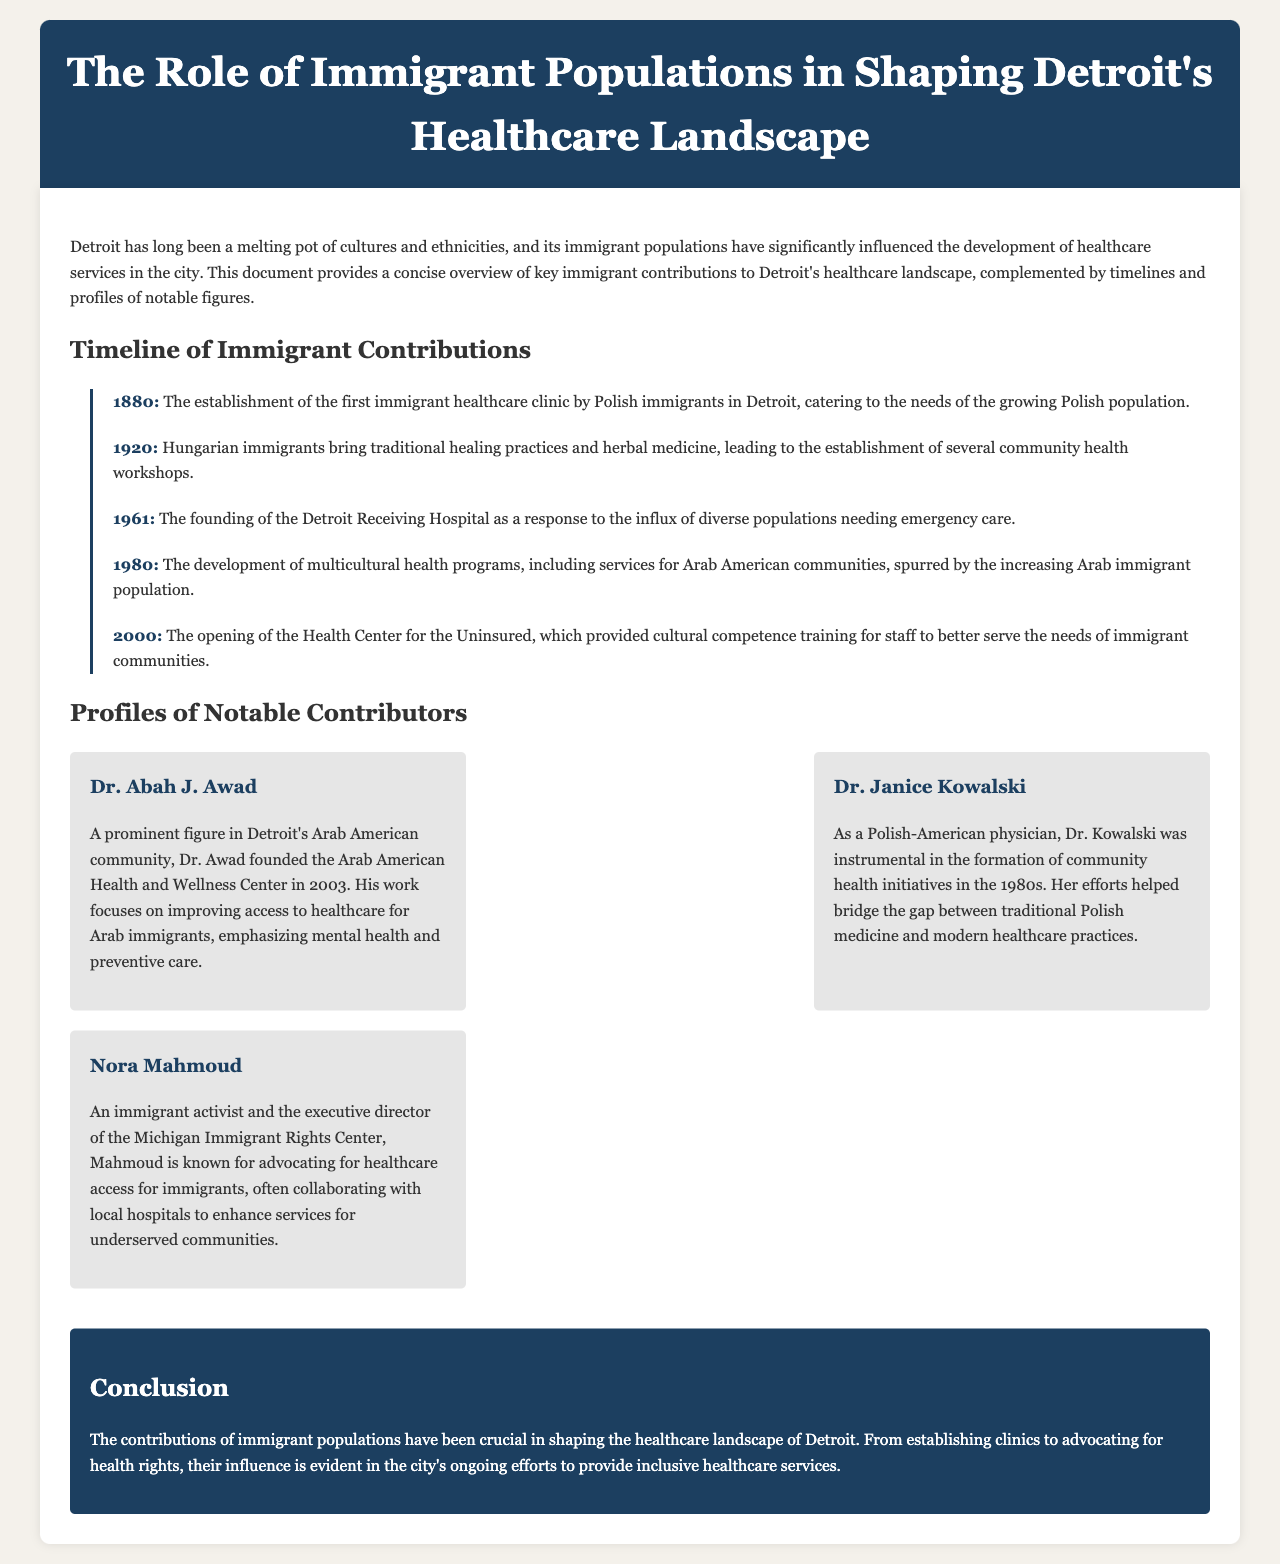What year was the first immigrant healthcare clinic established? The first immigrant healthcare clinic was established in the year 1880 according to the timeline in the document.
Answer: 1880 Who founded the Arab American Health and Wellness Center? The document states that Dr. Abah J. Awad founded the Arab American Health and Wellness Center in 2003.
Answer: Dr. Abah J. Awad What service was developed in 1980 for the Arab American communities? The timeline indicates that multicultural health programs were developed, specifically including services for Arab American communities in 1980.
Answer: Multicultural health programs Which immigrant group introduced traditional healing practices in 1920? The document notes that Hungarian immigrants brought traditional healing practices and herbal medicine in 1920.
Answer: Hungarian immigrants What major healthcare facility was founded in 1961? According to the timeline, the Detroit Receiving Hospital was founded in 1961 as a response to the diverse populations needing emergency care.
Answer: Detroit Receiving Hospital What is the focus of Dr. Awad's work? The document mentions that Dr. Awad's work focuses on improving access to healthcare for Arab immigrants, emphasizing mental health and preventive care.
Answer: Improving access to healthcare What year was the Health Center for the Uninsured opened? The timeline states that the Health Center for the Uninsured opened in the year 2000.
Answer: 2000 Who is known for advocating healthcare access for immigrants? The document identifies Nora Mahmoud as an immigrant activist known for advocating healthcare access for immigrants.
Answer: Nora Mahmoud 